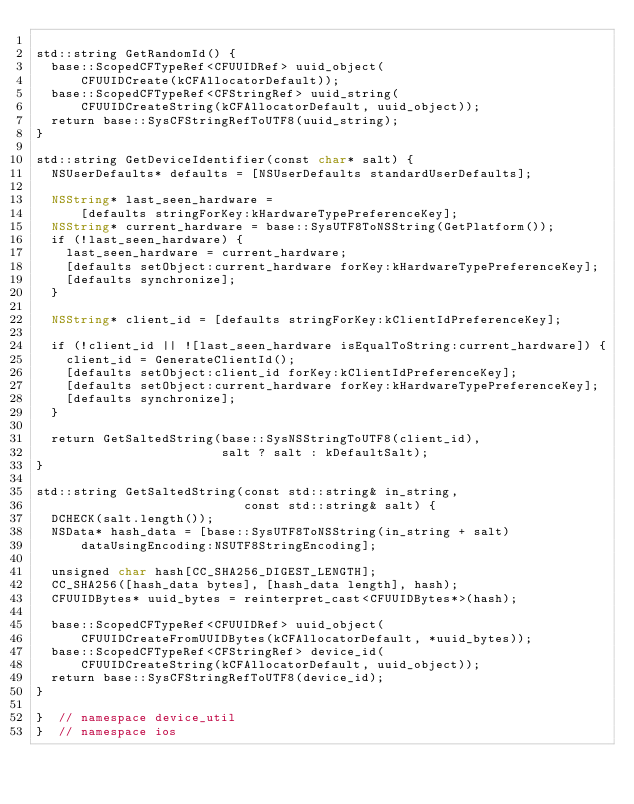Convert code to text. <code><loc_0><loc_0><loc_500><loc_500><_ObjectiveC_>
std::string GetRandomId() {
  base::ScopedCFTypeRef<CFUUIDRef> uuid_object(
      CFUUIDCreate(kCFAllocatorDefault));
  base::ScopedCFTypeRef<CFStringRef> uuid_string(
      CFUUIDCreateString(kCFAllocatorDefault, uuid_object));
  return base::SysCFStringRefToUTF8(uuid_string);
}

std::string GetDeviceIdentifier(const char* salt) {
  NSUserDefaults* defaults = [NSUserDefaults standardUserDefaults];

  NSString* last_seen_hardware =
      [defaults stringForKey:kHardwareTypePreferenceKey];
  NSString* current_hardware = base::SysUTF8ToNSString(GetPlatform());
  if (!last_seen_hardware) {
    last_seen_hardware = current_hardware;
    [defaults setObject:current_hardware forKey:kHardwareTypePreferenceKey];
    [defaults synchronize];
  }

  NSString* client_id = [defaults stringForKey:kClientIdPreferenceKey];

  if (!client_id || ![last_seen_hardware isEqualToString:current_hardware]) {
    client_id = GenerateClientId();
    [defaults setObject:client_id forKey:kClientIdPreferenceKey];
    [defaults setObject:current_hardware forKey:kHardwareTypePreferenceKey];
    [defaults synchronize];
  }

  return GetSaltedString(base::SysNSStringToUTF8(client_id),
                         salt ? salt : kDefaultSalt);
}

std::string GetSaltedString(const std::string& in_string,
                            const std::string& salt) {
  DCHECK(salt.length());
  NSData* hash_data = [base::SysUTF8ToNSString(in_string + salt)
      dataUsingEncoding:NSUTF8StringEncoding];

  unsigned char hash[CC_SHA256_DIGEST_LENGTH];
  CC_SHA256([hash_data bytes], [hash_data length], hash);
  CFUUIDBytes* uuid_bytes = reinterpret_cast<CFUUIDBytes*>(hash);

  base::ScopedCFTypeRef<CFUUIDRef> uuid_object(
      CFUUIDCreateFromUUIDBytes(kCFAllocatorDefault, *uuid_bytes));
  base::ScopedCFTypeRef<CFStringRef> device_id(
      CFUUIDCreateString(kCFAllocatorDefault, uuid_object));
  return base::SysCFStringRefToUTF8(device_id);
}

}  // namespace device_util
}  // namespace ios
</code> 